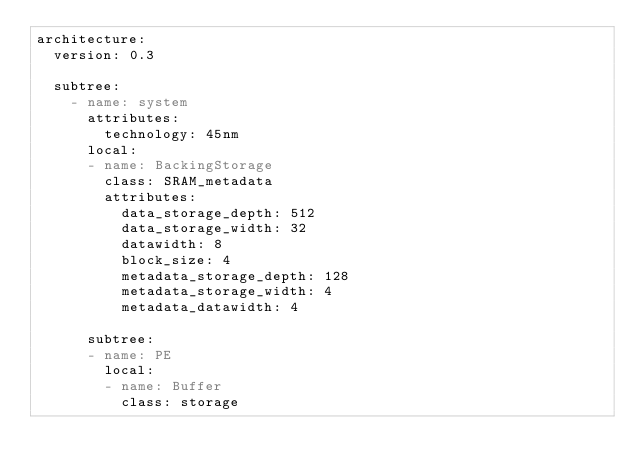Convert code to text. <code><loc_0><loc_0><loc_500><loc_500><_YAML_>architecture:
  version: 0.3

  subtree:
    - name: system
      attributes:
        technology: 45nm
      local:
      - name: BackingStorage
        class: SRAM_metadata
        attributes:
          data_storage_depth: 512
          data_storage_width: 32
          datawidth: 8
          block_size: 4
          metadata_storage_depth: 128
          metadata_storage_width: 4
          metadata_datawidth: 4

      subtree:
      - name: PE
        local:
        - name: Buffer
          class: storage</code> 